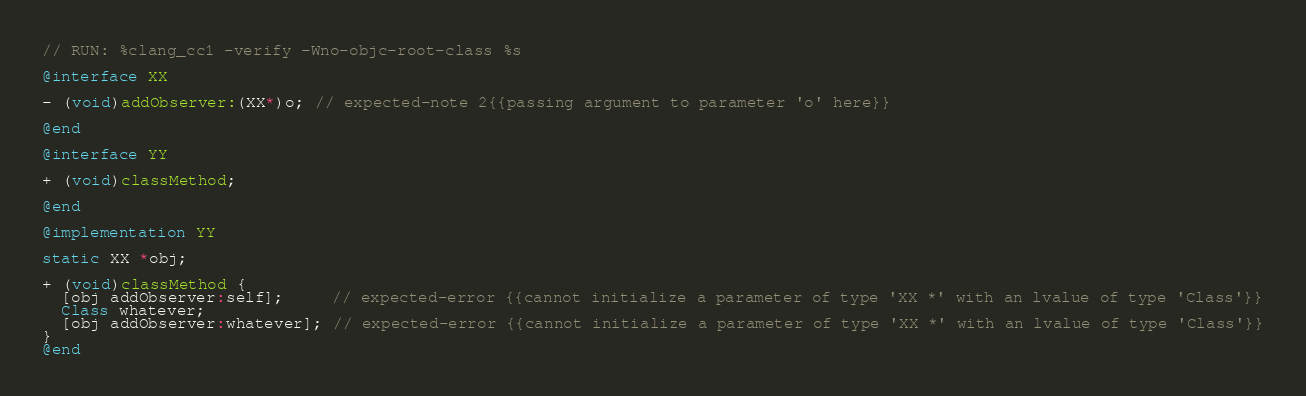Convert code to text. <code><loc_0><loc_0><loc_500><loc_500><_ObjectiveC_>// RUN: %clang_cc1 -verify -Wno-objc-root-class %s

@interface XX

- (void)addObserver:(XX*)o; // expected-note 2{{passing argument to parameter 'o' here}}

@end

@interface YY

+ (void)classMethod;

@end

@implementation YY

static XX *obj;

+ (void)classMethod {
  [obj addObserver:self];     // expected-error {{cannot initialize a parameter of type 'XX *' with an lvalue of type 'Class'}}
  Class whatever;
  [obj addObserver:whatever]; // expected-error {{cannot initialize a parameter of type 'XX *' with an lvalue of type 'Class'}}
}
@end

</code> 